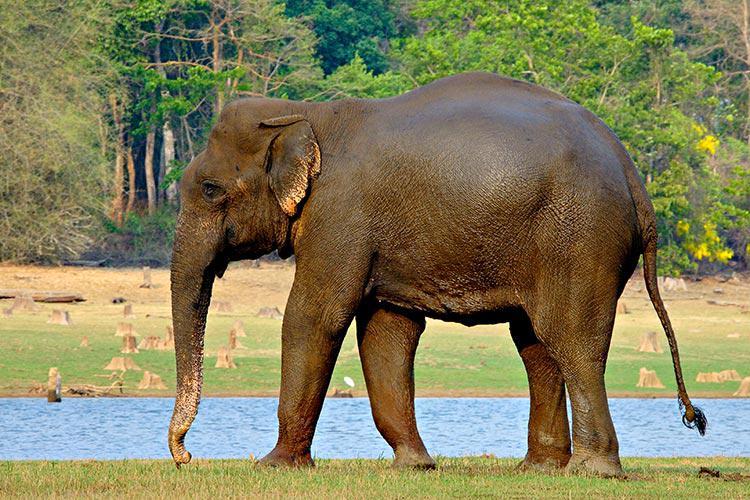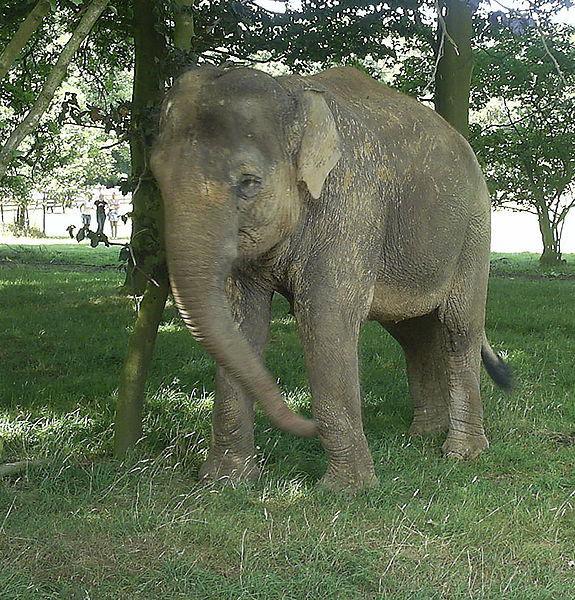The first image is the image on the left, the second image is the image on the right. For the images shown, is this caption "In one image, an elephant is in or near water." true? Answer yes or no. Yes. The first image is the image on the left, the second image is the image on the right. Given the left and right images, does the statement "A body of water is visible in one of the images." hold true? Answer yes or no. Yes. 